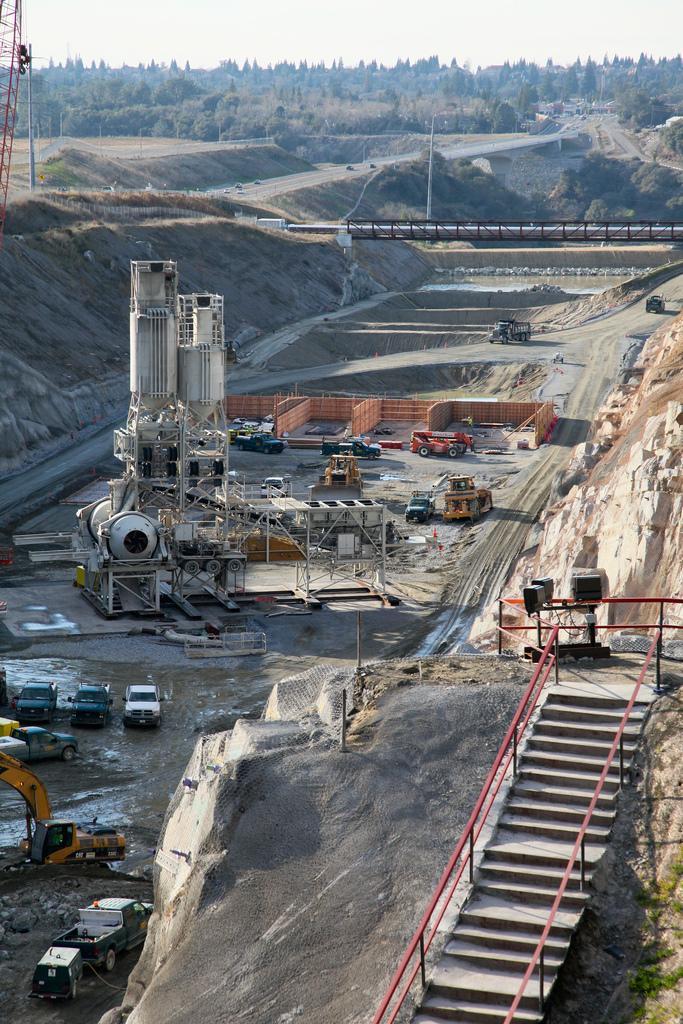In one or two sentences, can you explain what this image depicts? In the foreground I can see a staircase, metal rods, fleets of vehicles on the road, machines, fence, mountains, grass, bridge and sand. In the background I can see trees, light poles and the sky. This image is taken may be during a day. 